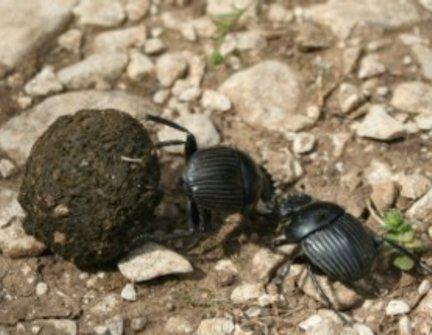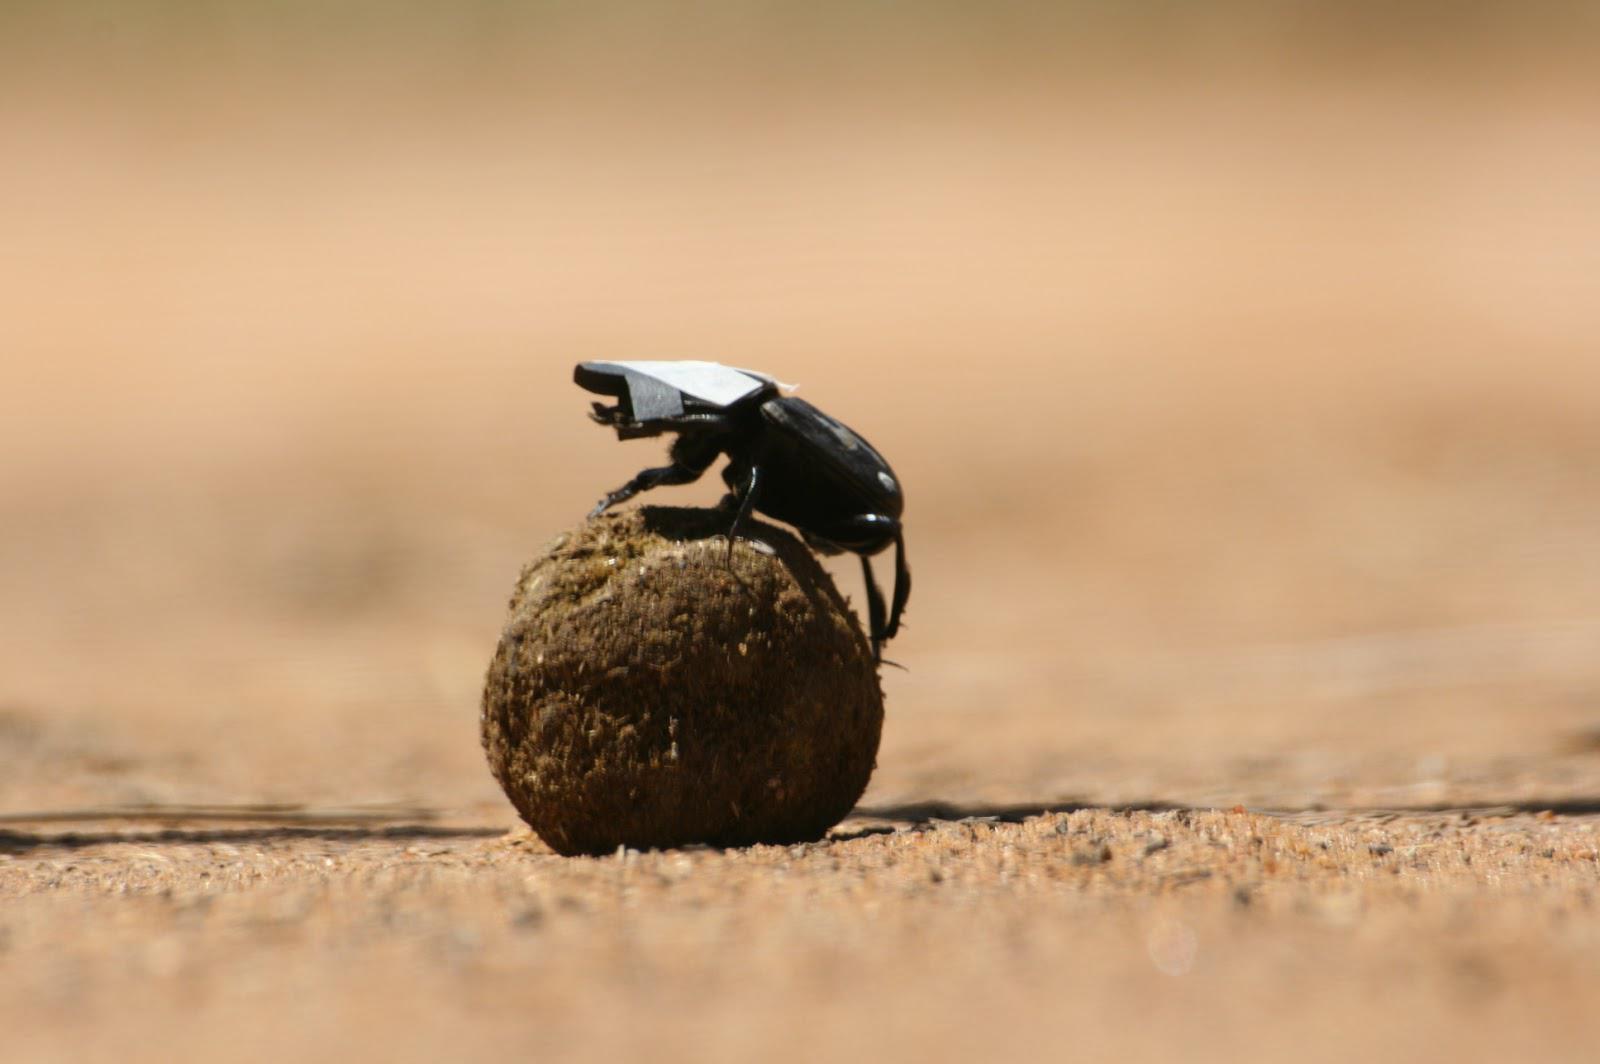The first image is the image on the left, the second image is the image on the right. Examine the images to the left and right. Is the description "An image in the pair shows exactly two beetles with a dung ball." accurate? Answer yes or no. Yes. The first image is the image on the left, the second image is the image on the right. Examine the images to the left and right. Is the description "Each image shows exactly one beetle." accurate? Answer yes or no. No. 